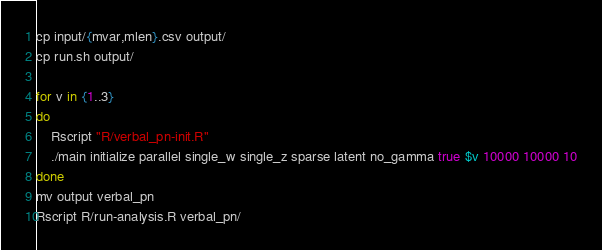<code> <loc_0><loc_0><loc_500><loc_500><_Bash_>cp input/{mvar,mlen}.csv output/
cp run.sh output/

for v in {1..3}
do
    Rscript "R/verbal_pn-init.R"
    ./main initialize parallel single_w single_z sparse latent no_gamma true $v 10000 10000 10
done
mv output verbal_pn
Rscript R/run-analysis.R verbal_pn/
</code> 